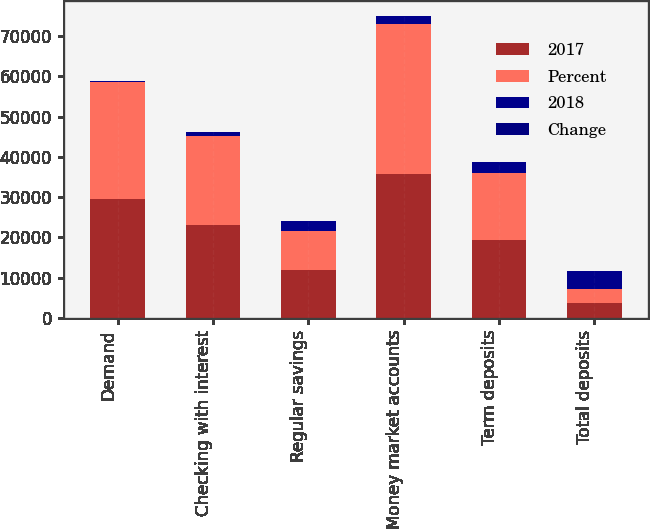<chart> <loc_0><loc_0><loc_500><loc_500><stacked_bar_chart><ecel><fcel>Demand<fcel>Checking with interest<fcel>Regular savings<fcel>Money market accounts<fcel>Term deposits<fcel>Total deposits<nl><fcel>2017<fcel>29458<fcel>23067<fcel>12007<fcel>35701<fcel>19342<fcel>3609.5<nl><fcel>Percent<fcel>29279<fcel>22229<fcel>9518<fcel>37454<fcel>16609<fcel>3609.5<nl><fcel>2018<fcel>179<fcel>838<fcel>2489<fcel>1753<fcel>2733<fcel>4486<nl><fcel>Change<fcel>1<fcel>4<fcel>26<fcel>5<fcel>16<fcel>4<nl></chart> 